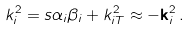Convert formula to latex. <formula><loc_0><loc_0><loc_500><loc_500>k _ { i } ^ { 2 } = s \alpha _ { i } \beta _ { i } + k _ { i T } ^ { 2 } \approx - \mathbf k _ { i } ^ { 2 } \, .</formula> 